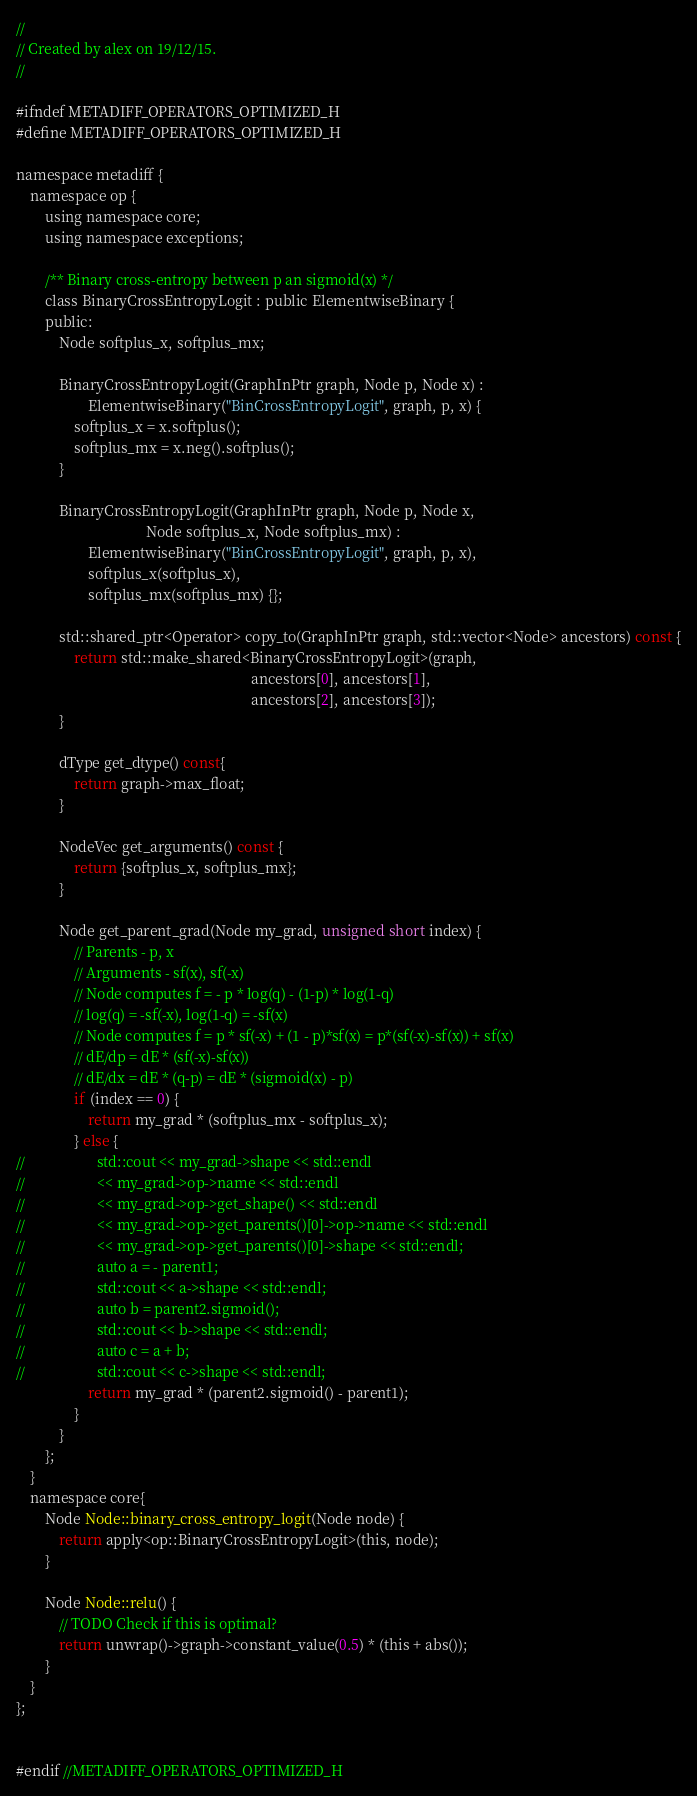<code> <loc_0><loc_0><loc_500><loc_500><_C_>//
// Created by alex on 19/12/15.
//

#ifndef METADIFF_OPERATORS_OPTIMIZED_H
#define METADIFF_OPERATORS_OPTIMIZED_H

namespace metadiff {
    namespace op {
        using namespace core;
        using namespace exceptions;

        /** Binary cross-entropy between p an sigmoid(x) */
        class BinaryCrossEntropyLogit : public ElementwiseBinary {
        public:
            Node softplus_x, softplus_mx;

            BinaryCrossEntropyLogit(GraphInPtr graph, Node p, Node x) :
                    ElementwiseBinary("BinCrossEntropyLogit", graph, p, x) {
                softplus_x = x.softplus();
                softplus_mx = x.neg().softplus();
            }

            BinaryCrossEntropyLogit(GraphInPtr graph, Node p, Node x,
                                    Node softplus_x, Node softplus_mx) :
                    ElementwiseBinary("BinCrossEntropyLogit", graph, p, x),
                    softplus_x(softplus_x),
                    softplus_mx(softplus_mx) {};

            std::shared_ptr<Operator> copy_to(GraphInPtr graph, std::vector<Node> ancestors) const {
                return std::make_shared<BinaryCrossEntropyLogit>(graph,
                                                                 ancestors[0], ancestors[1],
                                                                 ancestors[2], ancestors[3]);
            }

            dType get_dtype() const{
                return graph->max_float;
            }

            NodeVec get_arguments() const {
                return {softplus_x, softplus_mx};
            }

            Node get_parent_grad(Node my_grad, unsigned short index) {
                // Parents - p, x
                // Arguments - sf(x), sf(-x)
                // Node computes f = - p * log(q) - (1-p) * log(1-q)
                // log(q) = -sf(-x), log(1-q) = -sf(x)
                // Node computes f = p * sf(-x) + (1 - p)*sf(x) = p*(sf(-x)-sf(x)) + sf(x)
                // dE/dp = dE * (sf(-x)-sf(x))
                // dE/dx = dE * (q-p) = dE * (sigmoid(x) - p)
                if (index == 0) {
                    return my_grad * (softplus_mx - softplus_x);
                } else {
//                    std::cout << my_grad->shape << std::endl
//                    << my_grad->op->name << std::endl
//                    << my_grad->op->get_shape() << std::endl
//                    << my_grad->op->get_parents()[0]->op->name << std::endl
//                    << my_grad->op->get_parents()[0]->shape << std::endl;
//                    auto a = - parent1;
//                    std::cout << a->shape << std::endl;
//                    auto b = parent2.sigmoid();
//                    std::cout << b->shape << std::endl;
//                    auto c = a + b;
//                    std::cout << c->shape << std::endl;
                    return my_grad * (parent2.sigmoid() - parent1);
                }
            }
        };
    }
    namespace core{
        Node Node::binary_cross_entropy_logit(Node node) {
            return apply<op::BinaryCrossEntropyLogit>(this, node);
        }

        Node Node::relu() {
            // TODO Check if this is optimal?
            return unwrap()->graph->constant_value(0.5) * (this + abs());
        }
    }
};


#endif //METADIFF_OPERATORS_OPTIMIZED_H
</code> 